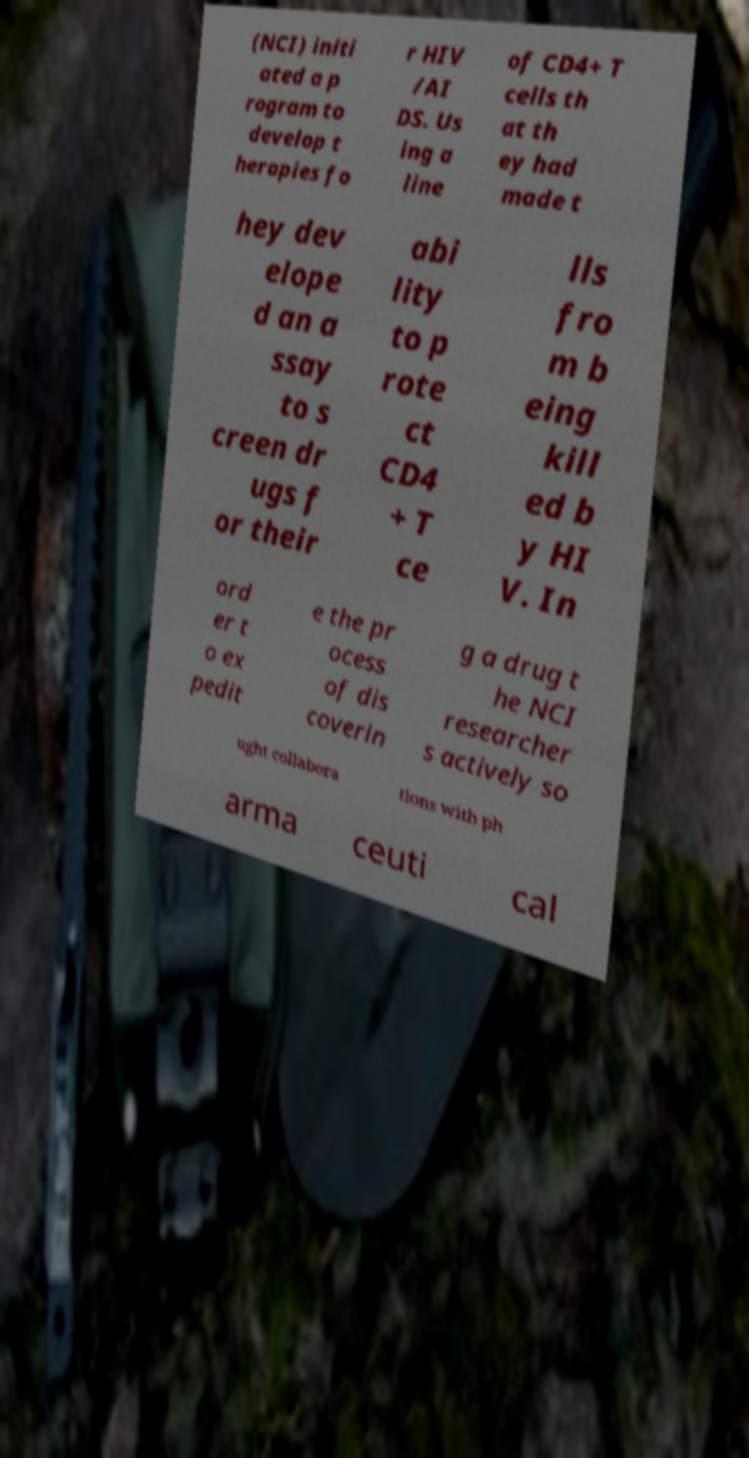Please identify and transcribe the text found in this image. (NCI) initi ated a p rogram to develop t herapies fo r HIV /AI DS. Us ing a line of CD4+ T cells th at th ey had made t hey dev elope d an a ssay to s creen dr ugs f or their abi lity to p rote ct CD4 + T ce lls fro m b eing kill ed b y HI V. In ord er t o ex pedit e the pr ocess of dis coverin g a drug t he NCI researcher s actively so ught collabora tions with ph arma ceuti cal 